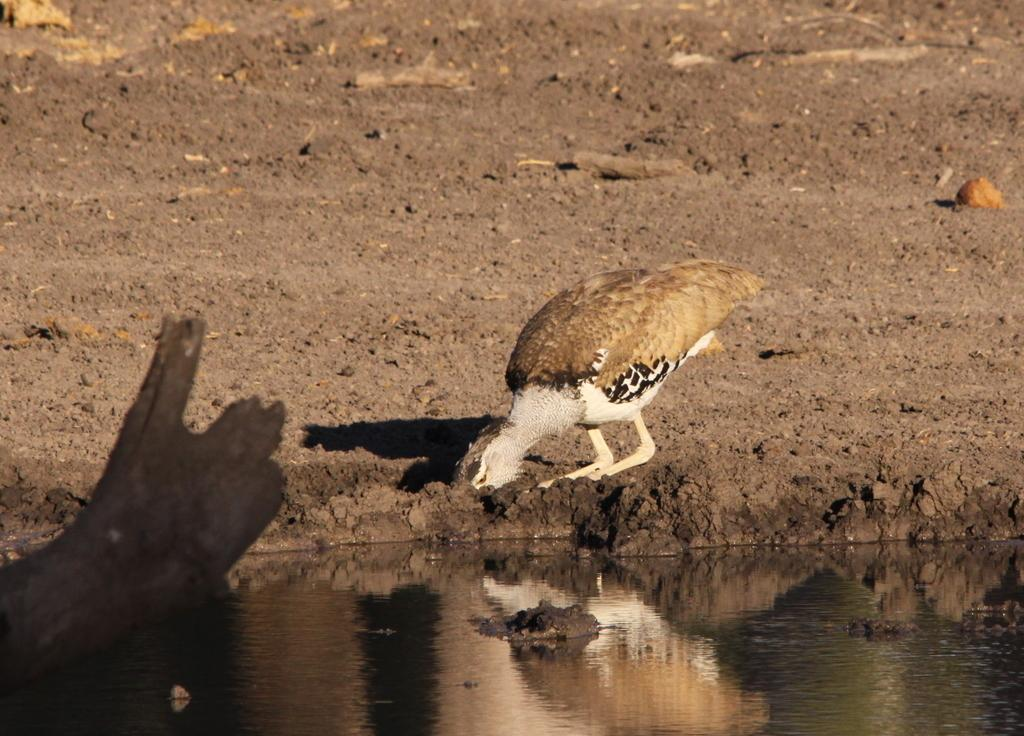What is the main subject in the center of the image? There is a bird in the center of the image. What is located at the bottom of the image? There is water at the bottom of the image. What can be seen on the left side of the image? There is a branch on the left side of the image. What type of paint is being used by the bird in the image? There is no paint or painting activity depicted in the image; it features a bird, water, and a branch. 